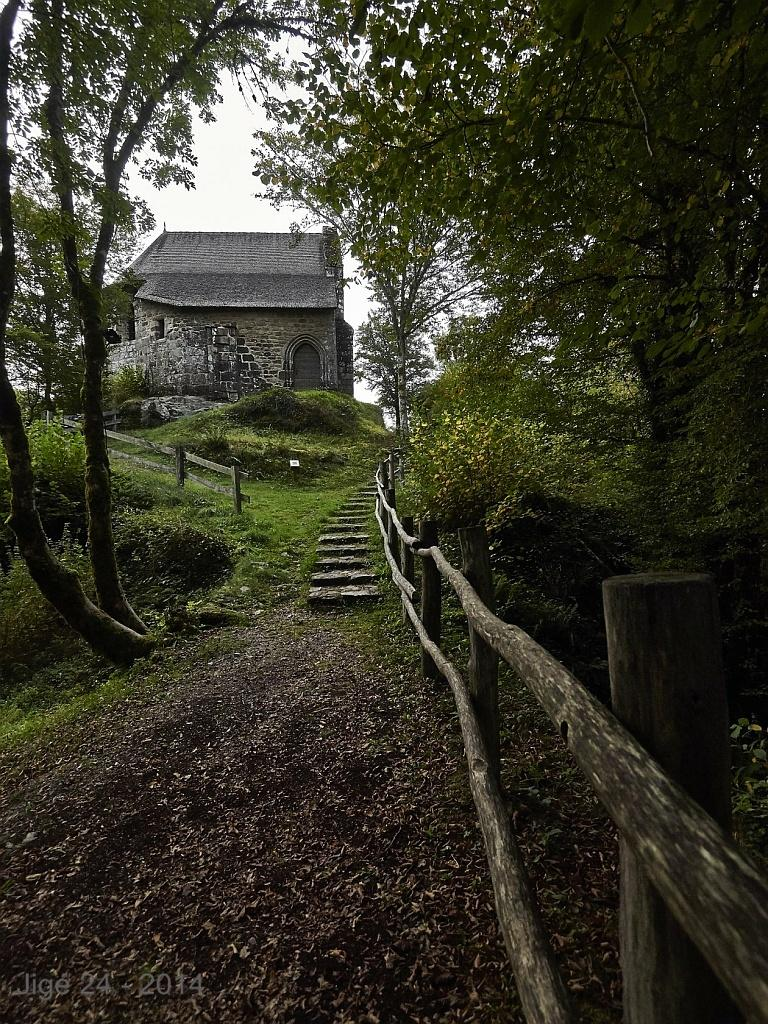What type of structure is present in the image? There is a house in the image. What features can be observed on the house? The house has a roof and a door. What type of vegetation is visible in the image? There is grass visible in the image. Are there any architectural elements present in the image? Yes, there is a staircase in the image. What type of barrier surrounds the property? There is a wooden fence in the image. What can be seen in the background of the image? There is a group of trees and the sky visible in the image. How would you describe the sky in the image? The sky appears to be cloudy in the image. How many glasses of water are on the floor in the image? There is no glass or water present on the floor in the image. 